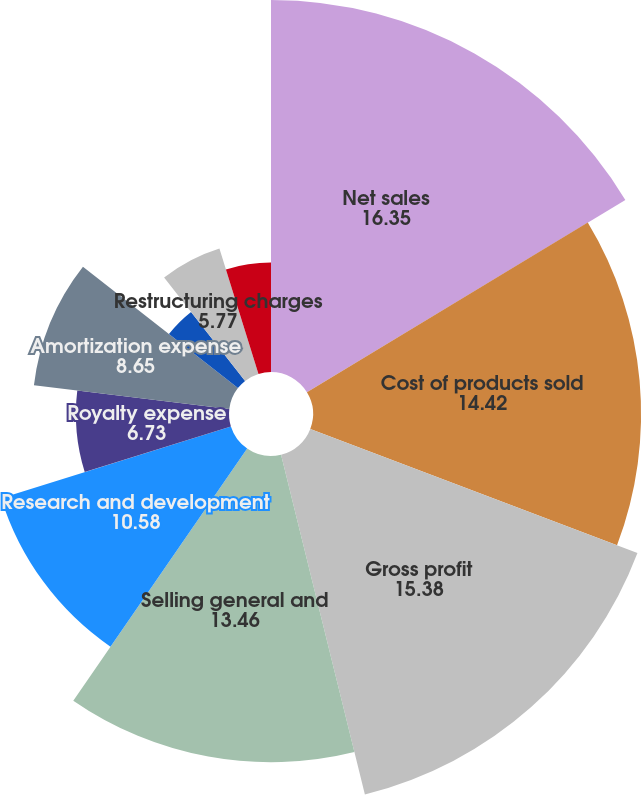Convert chart to OTSL. <chart><loc_0><loc_0><loc_500><loc_500><pie_chart><fcel>Net sales<fcel>Cost of products sold<fcel>Gross profit<fcel>Selling general and<fcel>Research and development<fcel>Royalty expense<fcel>Amortization expense<fcel>Intangible asset impairment<fcel>Restructuring charges<fcel>Litigation-related net<nl><fcel>16.35%<fcel>14.42%<fcel>15.38%<fcel>13.46%<fcel>10.58%<fcel>6.73%<fcel>8.65%<fcel>3.85%<fcel>5.77%<fcel>4.81%<nl></chart> 